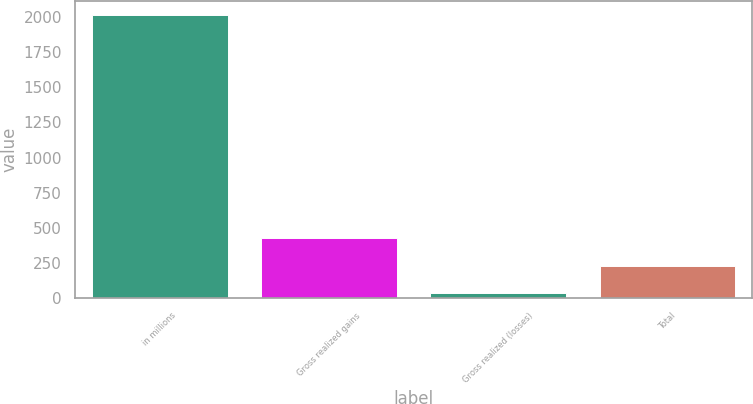Convert chart. <chart><loc_0><loc_0><loc_500><loc_500><bar_chart><fcel>in millions<fcel>Gross realized gains<fcel>Gross realized (losses)<fcel>Total<nl><fcel>2015<fcel>428.6<fcel>32<fcel>230.3<nl></chart> 